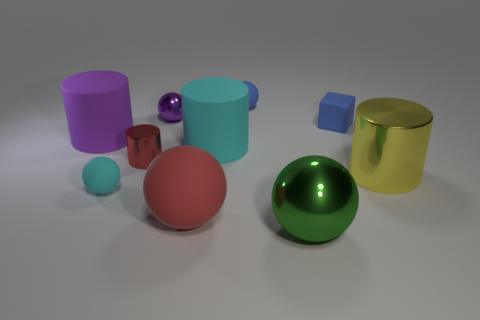Subtract all cyan rubber cylinders. How many cylinders are left? 3 Subtract 1 blocks. How many blocks are left? 0 Subtract all red cylinders. How many cylinders are left? 3 Subtract 0 yellow spheres. How many objects are left? 10 Subtract all blocks. How many objects are left? 9 Subtract all yellow blocks. Subtract all gray spheres. How many blocks are left? 1 Subtract all gray blocks. How many green balls are left? 1 Subtract all tiny blue objects. Subtract all small yellow matte objects. How many objects are left? 8 Add 5 big purple matte objects. How many big purple matte objects are left? 6 Add 7 brown things. How many brown things exist? 7 